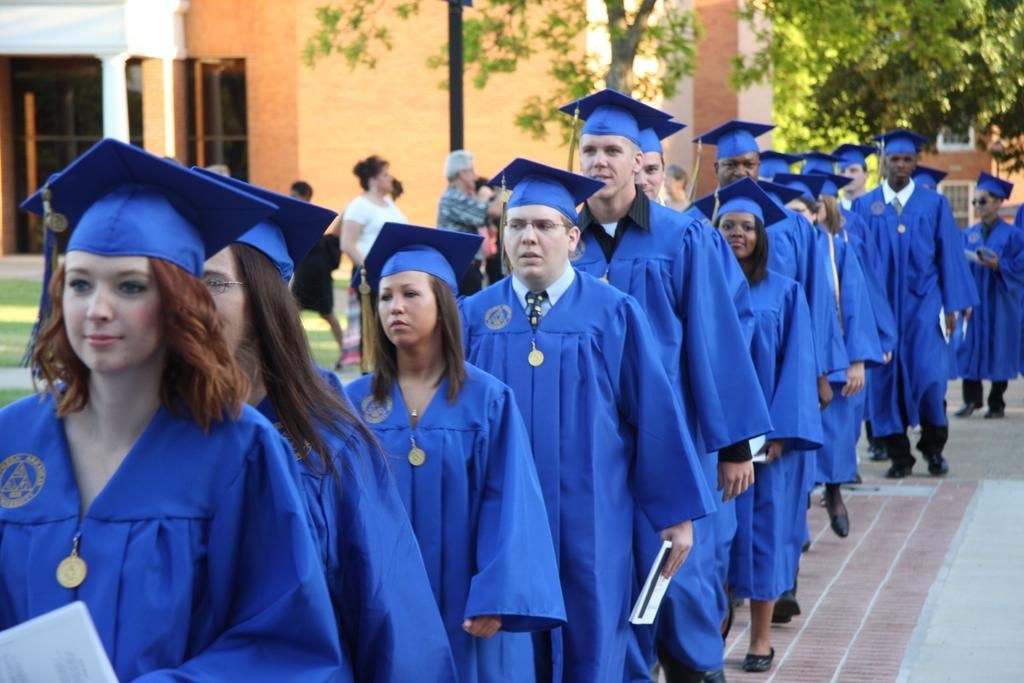Who or what can be seen in the image? There are people in the image. What type of surface can be seen in the image? There is a road in the image. What type of vegetation is present in the image? There is grass in the image. What structure can be seen in the image? There is a pole in the image. What type of man-made structures are visible in the image? There are buildings in the image. What other natural elements can be seen in the image? There are trees in the image. What type of breakfast is being served in the image? There is no breakfast visible in the image; it does not depict a meal or dining setting. 